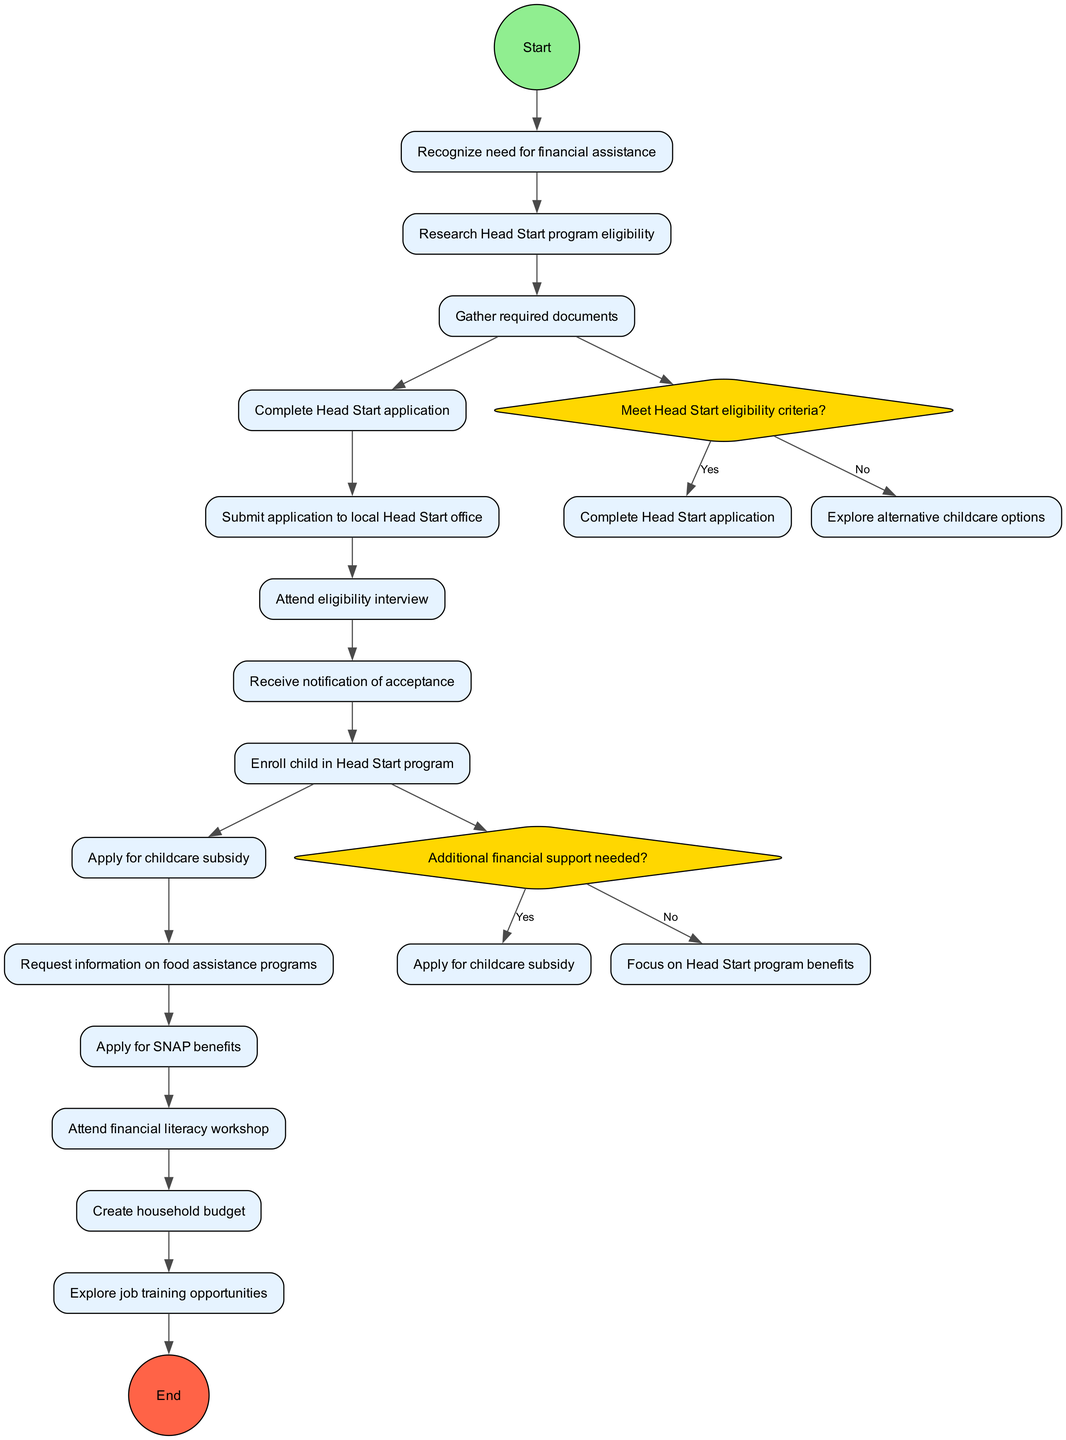What is the first activity mentioned in the diagram? The diagram starts with the first activity labeled "Research Head Start program eligibility". This is the activity that follows the initial recognition of the need for financial assistance.
Answer: Research Head Start program eligibility How many decision points are in the diagram? The diagram contains two decision points. These decision points are represented by diamond-shaped nodes which evaluate specific conditions regarding financial assistance.
Answer: 2 What happens if the eligibility criteria for Head Start are met? If the eligibility criteria for Head Start are met, the process leads to the "Complete Head Start application" activity, indicating that the applicant should proceed with filling out the application forms.
Answer: Complete Head Start application What is the last activity before ending the process? The last activity before reaching the end of the diagram is "Explore job training opportunities". This activity is part of utilizing support services effectively.
Answer: Explore job training opportunities What is the consequence of not meeting the Head Start eligibility criteria? If the Head Start eligibility criteria are not met, the diagram indicates that one should "Explore alternative childcare options", which is a pathway to finding other childcare solutions.
Answer: Explore alternative childcare options What type of support is applied for after attending the eligibility interview? After attending the eligibility interview, the next step is to apply for the "childcare subsidy", which provides additional financial support for childcare needs.
Answer: childcare subsidy How does one access food assistance programs according to the diagram? According to the diagram, food assistance programs can be accessed by requesting information on them after enrolling in the Head Start program. This step indicates a proactive approach to addressing food needs.
Answer: Request information on food assistance programs What follows after receiving the notification of acceptance into the Head Start program? After receiving notification of acceptance into the Head Start program, the next step is to "Enroll child in Head Start program", which involves officially registering the child to begin receiving services.
Answer: Enroll child in Head Start program 